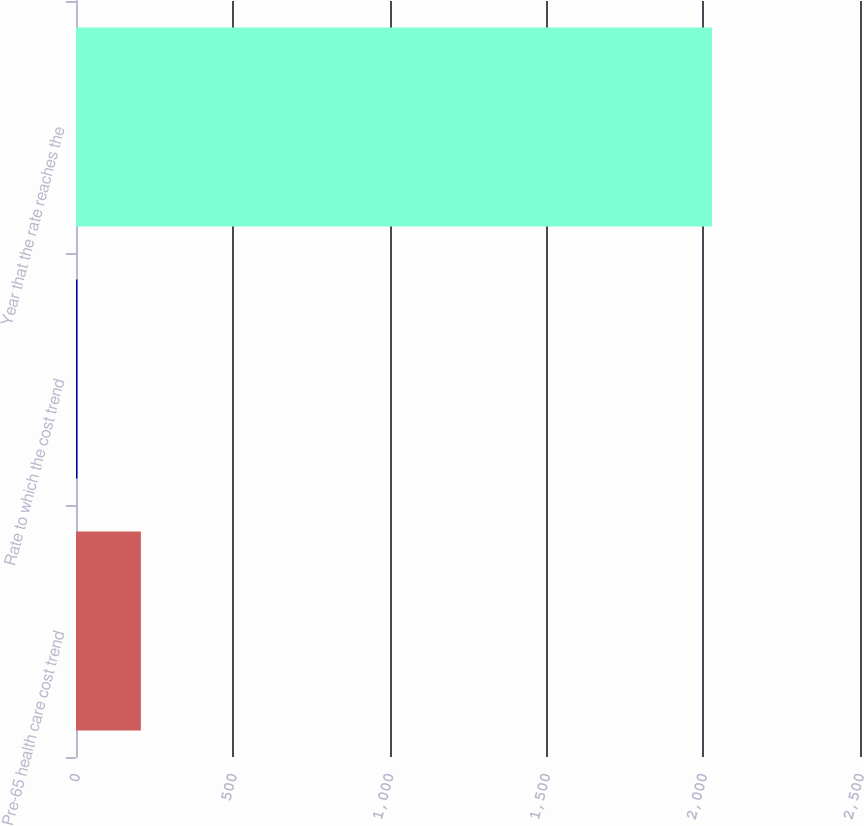<chart> <loc_0><loc_0><loc_500><loc_500><bar_chart><fcel>Pre-65 health care cost trend<fcel>Rate to which the cost trend<fcel>Year that the rate reaches the<nl><fcel>206.85<fcel>4.5<fcel>2028<nl></chart> 